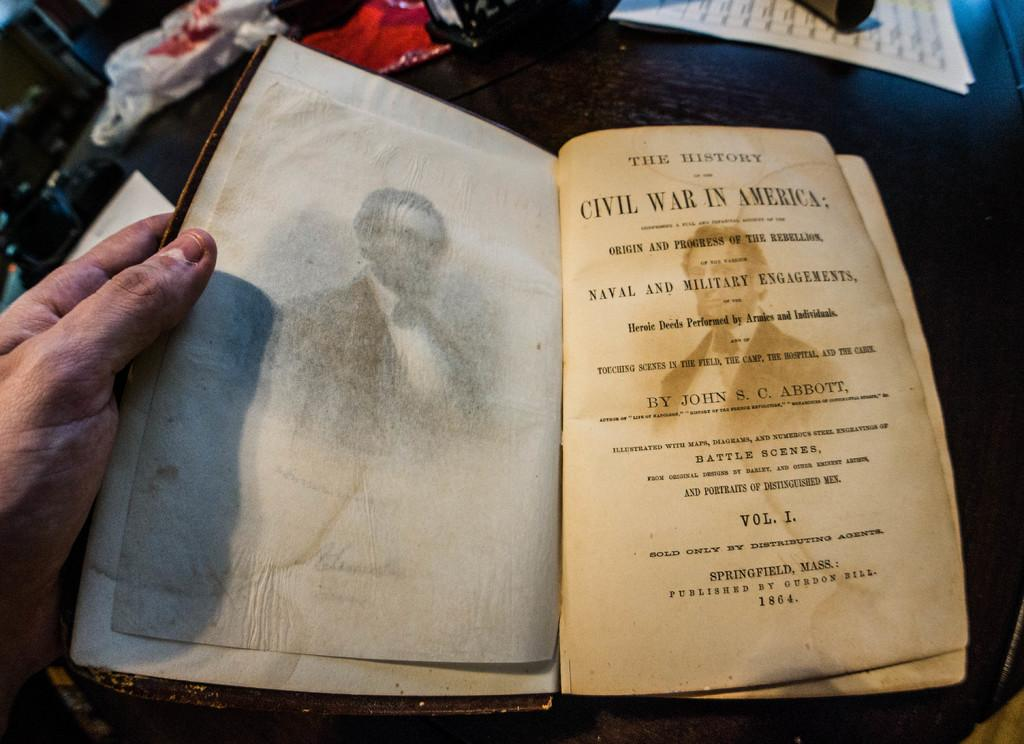Who is present in the image? There is a person in the image. What is the person holding? The person is holding a book. What can be seen on the table in the image? There are papers and other objects on a table in the image. What type of scarecrow is present in the image? There is no scarecrow present in the image. How many shelves can be seen in the image? There is no shelf present in the image. 